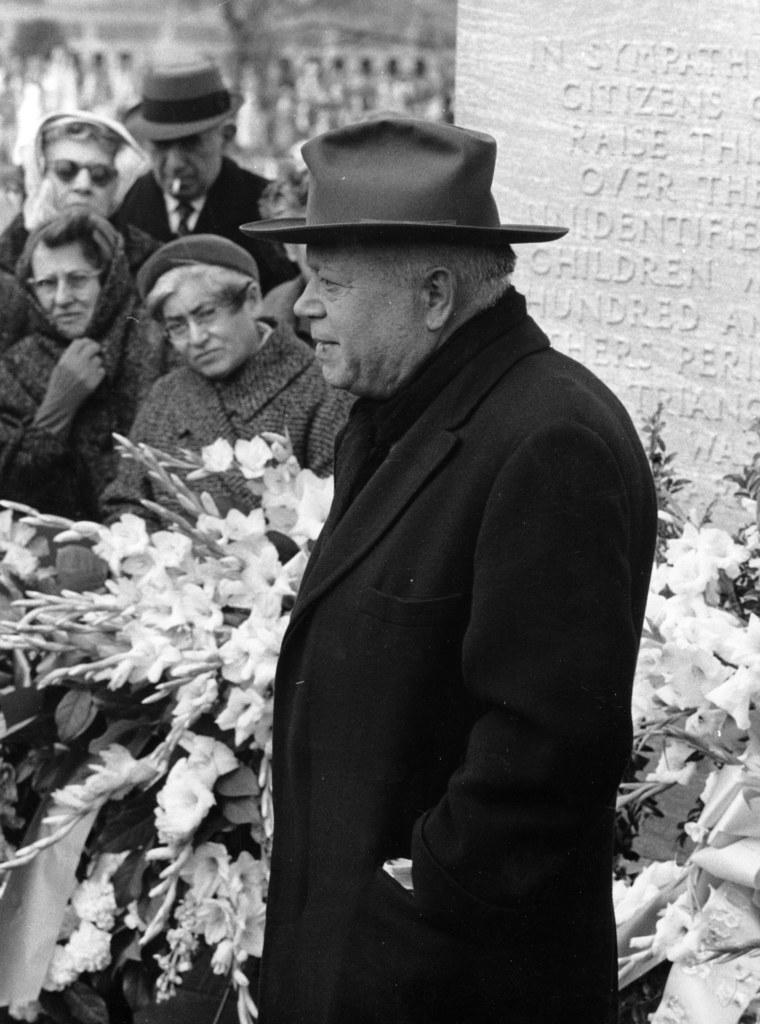What type of living organisms can be seen in the image? There are flowers in the image. What else is present in the image besides the flowers? There are people standing in the image. What is the color scheme of the image? The image is in black and white. What type of insurance policy is being discussed by the people in the image? There is no indication in the image that the people are discussing any insurance policies. What is the drainage system like in the area where the image was taken? There is no information about the drainage system in the image or the area where it was taken. 